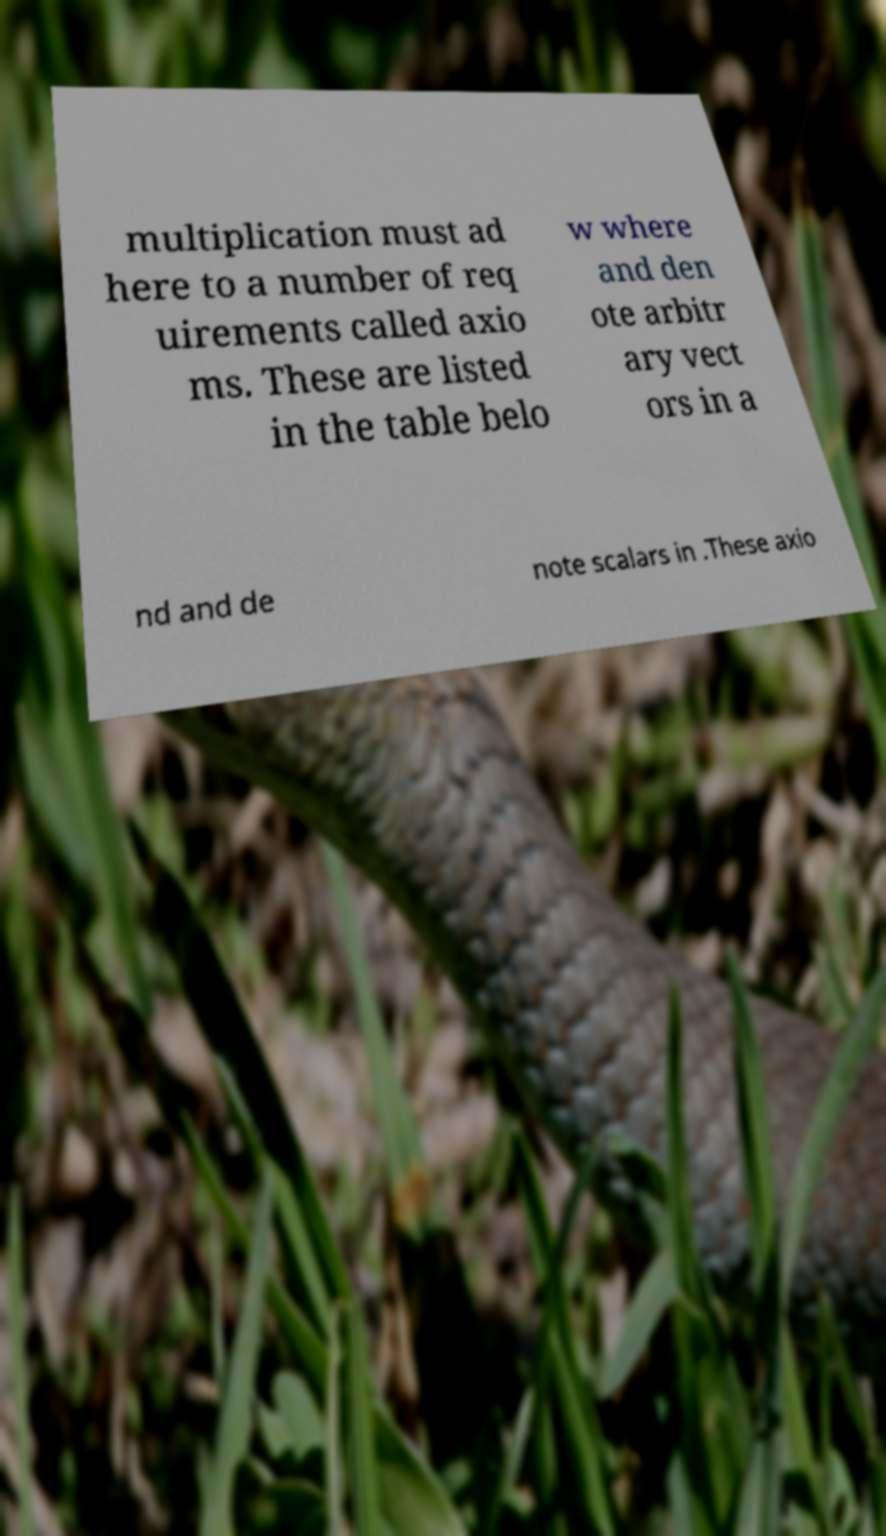I need the written content from this picture converted into text. Can you do that? multiplication must ad here to a number of req uirements called axio ms. These are listed in the table belo w where and den ote arbitr ary vect ors in a nd and de note scalars in .These axio 